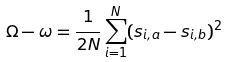Convert formula to latex. <formula><loc_0><loc_0><loc_500><loc_500>\Omega - \omega = \frac { 1 } { 2 N } \sum _ { i = 1 } ^ { N } ( s _ { i , a } - s _ { i , b } ) ^ { 2 }</formula> 